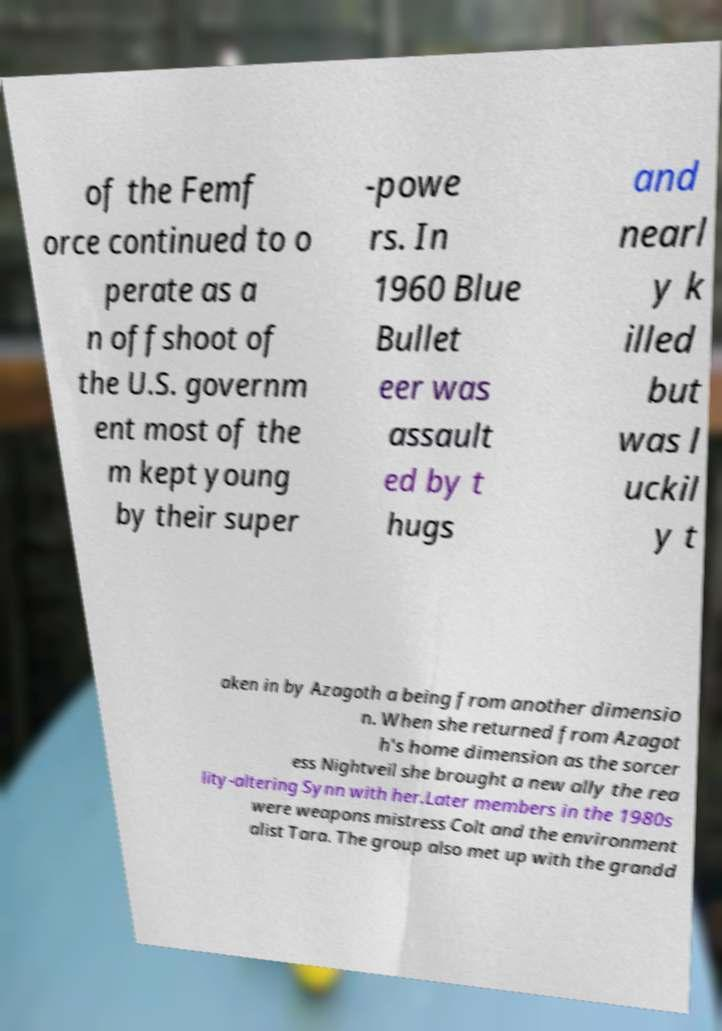Please read and relay the text visible in this image. What does it say? of the Femf orce continued to o perate as a n offshoot of the U.S. governm ent most of the m kept young by their super -powe rs. In 1960 Blue Bullet eer was assault ed by t hugs and nearl y k illed but was l uckil y t aken in by Azagoth a being from another dimensio n. When she returned from Azagot h's home dimension as the sorcer ess Nightveil she brought a new ally the rea lity-altering Synn with her.Later members in the 1980s were weapons mistress Colt and the environment alist Tara. The group also met up with the grandd 